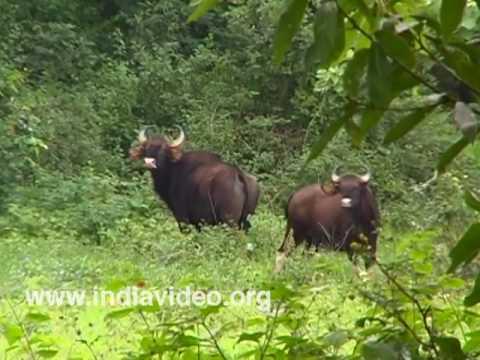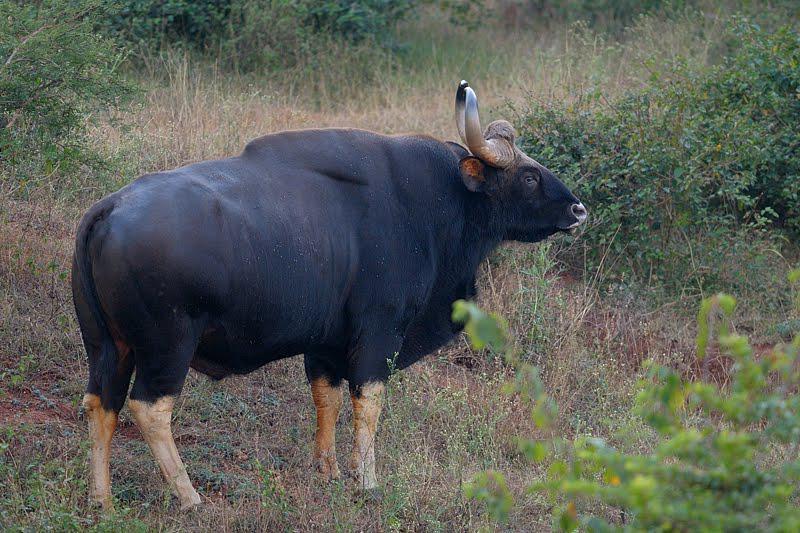The first image is the image on the left, the second image is the image on the right. Analyze the images presented: Is the assertion "The left image contains two water buffalo's." valid? Answer yes or no. Yes. The first image is the image on the left, the second image is the image on the right. Considering the images on both sides, is "Left image contains twice as many hooved animals as the right image." valid? Answer yes or no. Yes. 